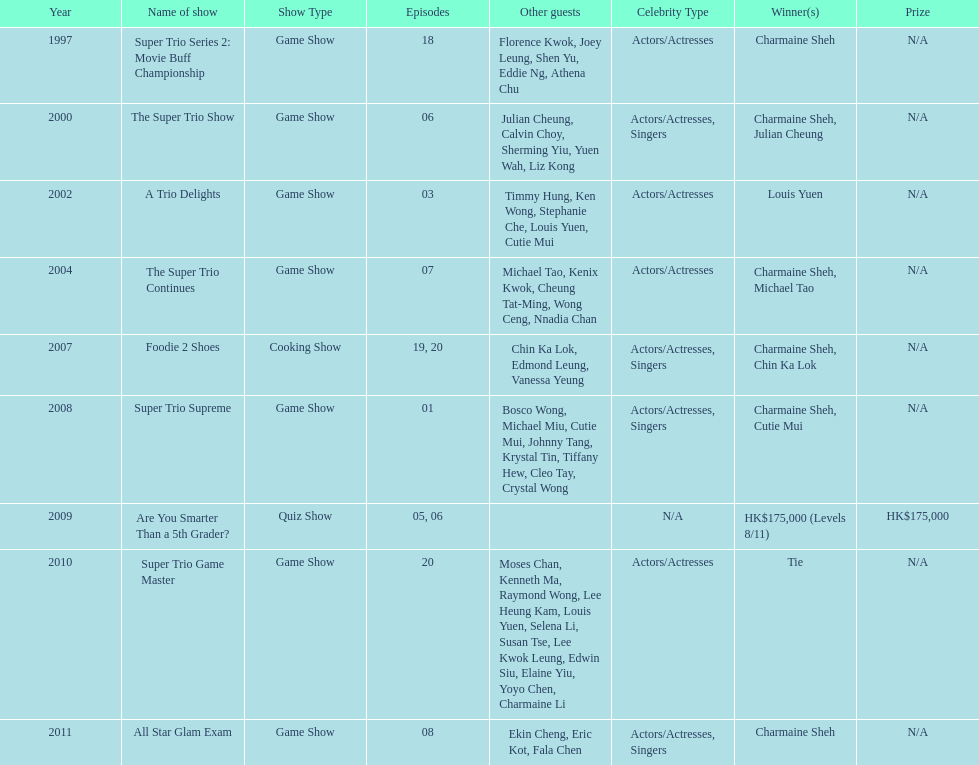What is the count of tv shows charmaine sheh has participated in? 9. 